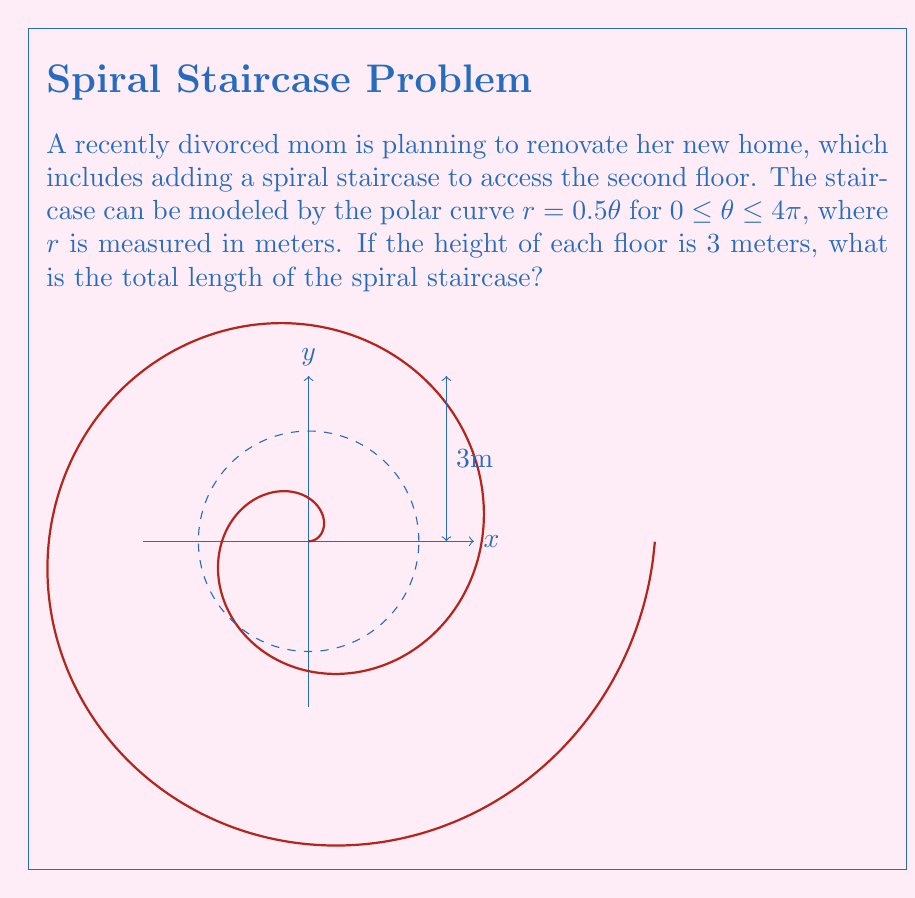Provide a solution to this math problem. Let's approach this step-by-step:

1) The length of a polar curve is given by the formula:

   $$L = \int_a^b \sqrt{r^2 + \left(\frac{dr}{d\theta}\right)^2} d\theta$$

2) In our case, $r = 0.5\theta$, so $\frac{dr}{d\theta} = 0.5$

3) Substituting these into the formula:

   $$L = \int_0^{4\pi} \sqrt{(0.5\theta)^2 + (0.5)^2} d\theta$$

4) Simplify under the square root:

   $$L = \int_0^{4\pi} \sqrt{0.25\theta^2 + 0.25} d\theta = 0.5\int_0^{4\pi} \sqrt{\theta^2 + 1} d\theta$$

5) This integral can be solved using the substitution $\theta = \sinh u$:

   $$L = 0.5 \left[\theta\sqrt{\theta^2+1} + \ln(\theta + \sqrt{\theta^2+1})\right]_0^{4\pi}$$

6) Evaluating at the limits:

   $$L = 0.5 \left[4\pi\sqrt{16\pi^2+1} + \ln(4\pi + \sqrt{16\pi^2+1}) - 0\right]$$

7) This gives us the length of the spiral curve. However, we need to consider the vertical distance too.

8) The vertical distance is simply the height of the floor, which is 3 meters.

9) To get the total length, we use the Pythagorean theorem:

   $$\text{Total Length} = \sqrt{L^2 + 3^2}$$

10) Calculating this (you may use a calculator) gives approximately 25.51 meters.
Answer: $\sqrt{(2\pi\sqrt{16\pi^2+1} + \ln(4\pi + \sqrt{16\pi^2+1}))^2 + 9} \approx 25.51$ meters 